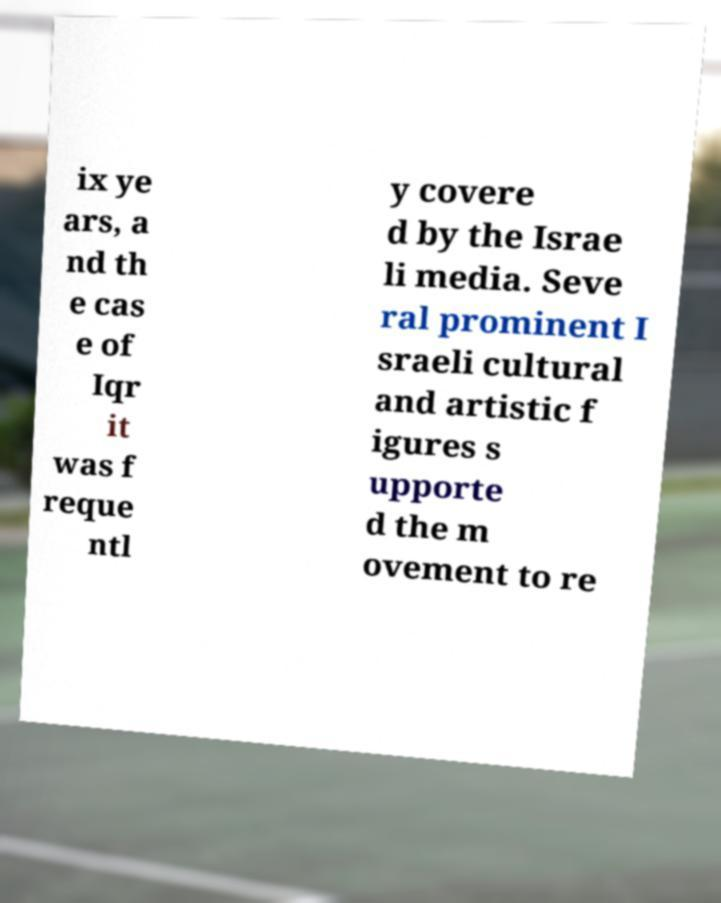Can you read and provide the text displayed in the image?This photo seems to have some interesting text. Can you extract and type it out for me? ix ye ars, a nd th e cas e of Iqr it was f reque ntl y covere d by the Israe li media. Seve ral prominent I sraeli cultural and artistic f igures s upporte d the m ovement to re 